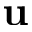Convert formula to latex. <formula><loc_0><loc_0><loc_500><loc_500>u</formula> 